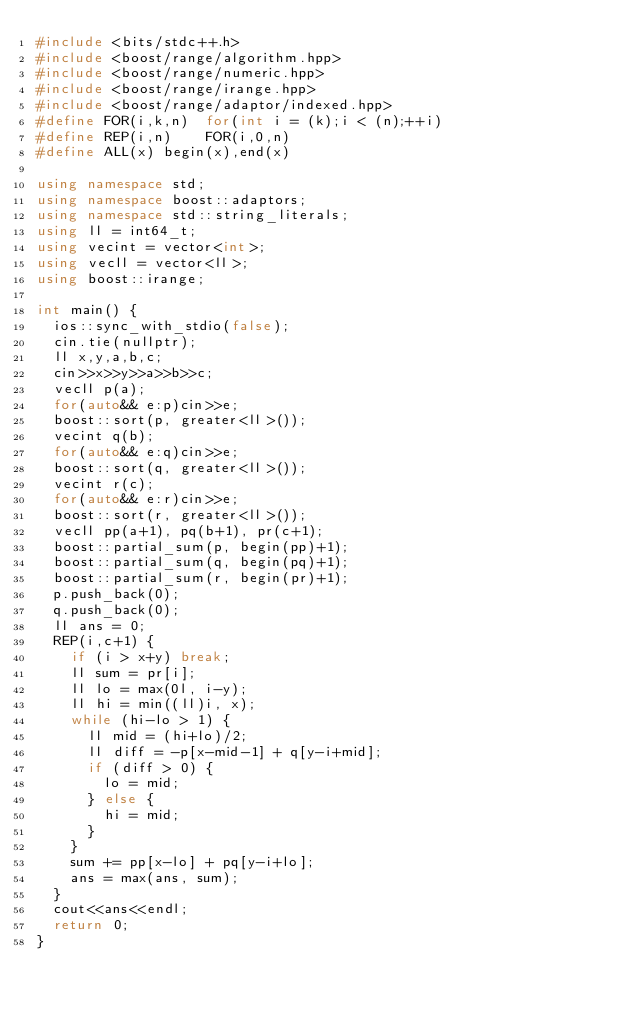Convert code to text. <code><loc_0><loc_0><loc_500><loc_500><_C++_>#include <bits/stdc++.h>
#include <boost/range/algorithm.hpp>
#include <boost/range/numeric.hpp>
#include <boost/range/irange.hpp>
#include <boost/range/adaptor/indexed.hpp>
#define FOR(i,k,n)  for(int i = (k);i < (n);++i)
#define REP(i,n)    FOR(i,0,n)
#define ALL(x) begin(x),end(x)

using namespace std;
using namespace boost::adaptors;
using namespace std::string_literals;
using ll = int64_t;
using vecint = vector<int>;
using vecll = vector<ll>;
using boost::irange;

int main() {
  ios::sync_with_stdio(false);
  cin.tie(nullptr);
  ll x,y,a,b,c;
  cin>>x>>y>>a>>b>>c;
  vecll p(a);
  for(auto&& e:p)cin>>e;
  boost::sort(p, greater<ll>());
  vecint q(b);
  for(auto&& e:q)cin>>e;
  boost::sort(q, greater<ll>());
  vecint r(c);
  for(auto&& e:r)cin>>e;
  boost::sort(r, greater<ll>());
  vecll pp(a+1), pq(b+1), pr(c+1);
  boost::partial_sum(p, begin(pp)+1);
  boost::partial_sum(q, begin(pq)+1);
  boost::partial_sum(r, begin(pr)+1);
  p.push_back(0);
  q.push_back(0);
  ll ans = 0;
  REP(i,c+1) {
    if (i > x+y) break;
    ll sum = pr[i];
    ll lo = max(0l, i-y);
    ll hi = min((ll)i, x);
    while (hi-lo > 1) {
      ll mid = (hi+lo)/2;
      ll diff = -p[x-mid-1] + q[y-i+mid];
      if (diff > 0) {
        lo = mid;
      } else {
        hi = mid;
      }
    }
    sum += pp[x-lo] + pq[y-i+lo];
    ans = max(ans, sum);
  }
  cout<<ans<<endl;
  return 0;
}
</code> 